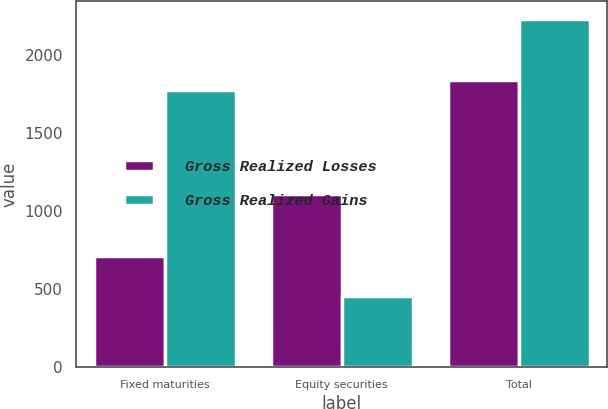<chart> <loc_0><loc_0><loc_500><loc_500><stacked_bar_chart><ecel><fcel>Fixed maturities<fcel>Equity securities<fcel>Total<nl><fcel>Gross Realized Losses<fcel>711<fcel>1111<fcel>1844<nl><fcel>Gross Realized Gains<fcel>1780<fcel>454<fcel>2234<nl></chart> 